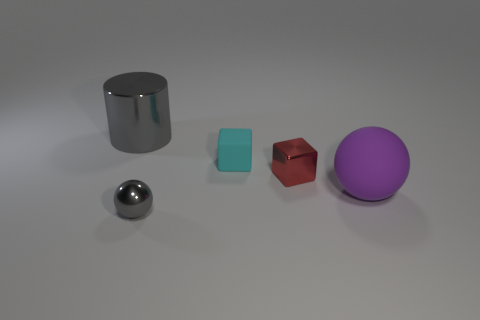Are the large sphere and the cyan thing made of the same material?
Your answer should be compact. Yes. How many cylinders are either small cyan objects or small gray shiny things?
Offer a very short reply. 0. The small object behind the red cube is what color?
Give a very brief answer. Cyan. How many shiny objects are tiny gray balls or large yellow things?
Provide a short and direct response. 1. What material is the sphere that is right of the matte object behind the rubber ball?
Provide a short and direct response. Rubber. What is the color of the tiny metallic cube?
Offer a very short reply. Red. There is a metal thing right of the gray shiny sphere; are there any small blocks to the left of it?
Offer a terse response. Yes. What material is the purple object?
Your answer should be very brief. Rubber. Does the object that is behind the small cyan rubber thing have the same material as the small gray ball that is in front of the cylinder?
Offer a very short reply. Yes. Are there any other things that have the same color as the tiny ball?
Keep it short and to the point. Yes. 